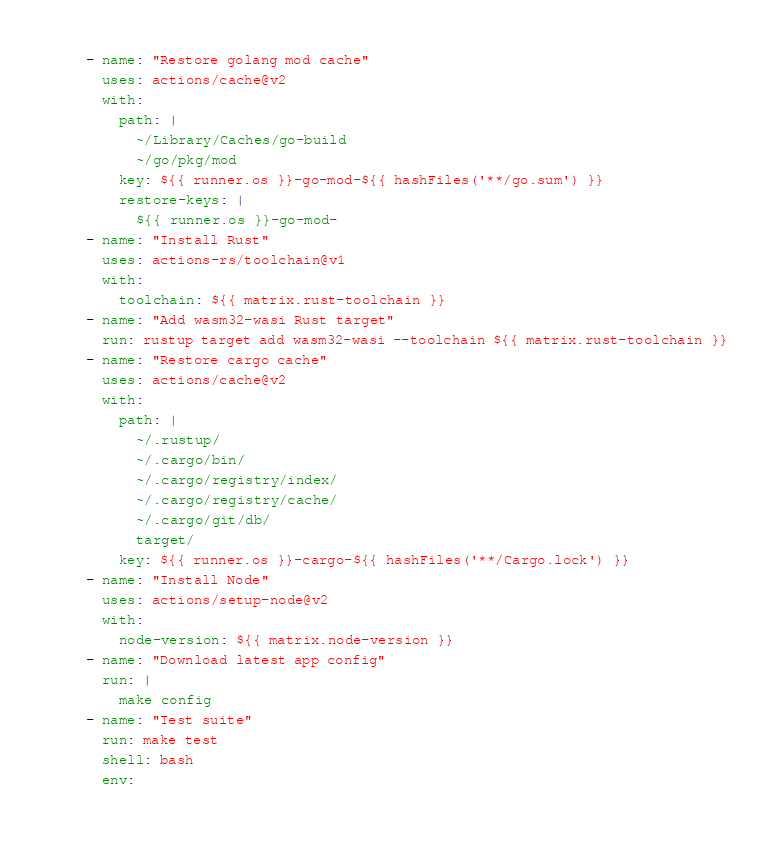<code> <loc_0><loc_0><loc_500><loc_500><_YAML_>    - name: "Restore golang mod cache"
      uses: actions/cache@v2
      with:
        path: |
          ~/Library/Caches/go-build
          ~/go/pkg/mod
        key: ${{ runner.os }}-go-mod-${{ hashFiles('**/go.sum') }}
        restore-keys: |
          ${{ runner.os }}-go-mod-
    - name: "Install Rust"
      uses: actions-rs/toolchain@v1
      with:
        toolchain: ${{ matrix.rust-toolchain }}
    - name: "Add wasm32-wasi Rust target"
      run: rustup target add wasm32-wasi --toolchain ${{ matrix.rust-toolchain }}
    - name: "Restore cargo cache"
      uses: actions/cache@v2
      with:
        path: |
          ~/.rustup/
          ~/.cargo/bin/
          ~/.cargo/registry/index/
          ~/.cargo/registry/cache/
          ~/.cargo/git/db/
          target/
        key: ${{ runner.os }}-cargo-${{ hashFiles('**/Cargo.lock') }}
    - name: "Install Node"
      uses: actions/setup-node@v2
      with:
        node-version: ${{ matrix.node-version }}
    - name: "Download latest app config"
      run: |
        make config
    - name: "Test suite"
      run: make test
      shell: bash
      env:</code> 